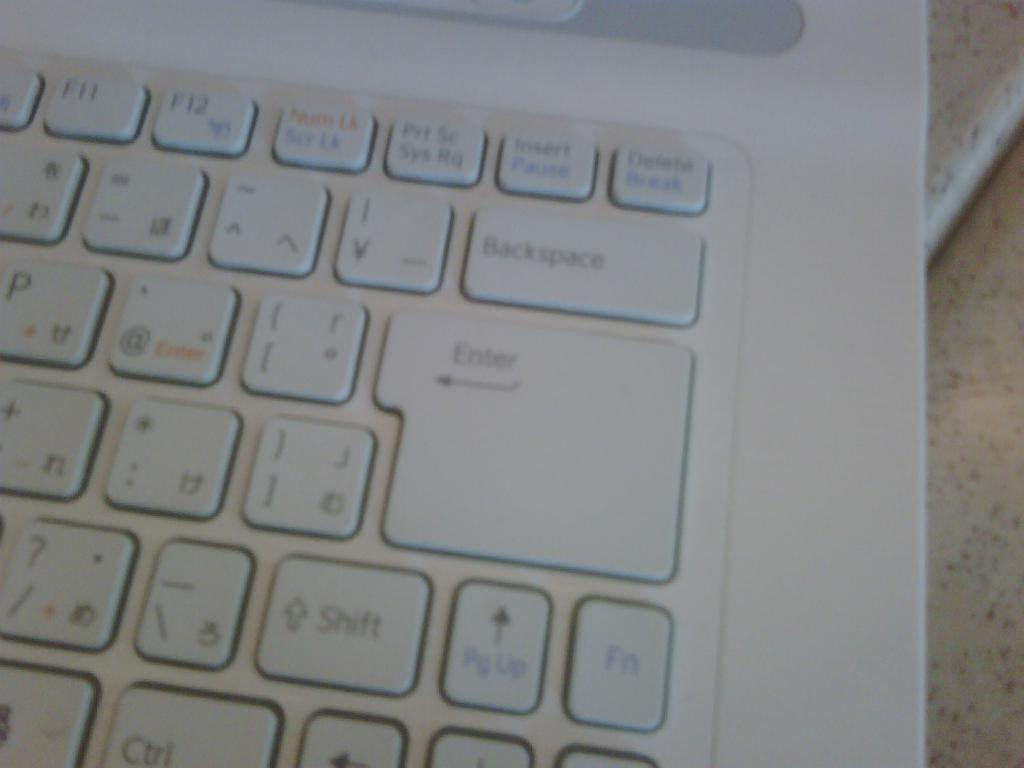<image>
Create a compact narrative representing the image presented. White laptop with a Backspace key above a large enter key. 